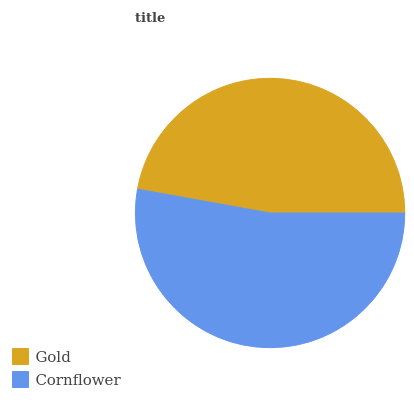Is Gold the minimum?
Answer yes or no. Yes. Is Cornflower the maximum?
Answer yes or no. Yes. Is Cornflower the minimum?
Answer yes or no. No. Is Cornflower greater than Gold?
Answer yes or no. Yes. Is Gold less than Cornflower?
Answer yes or no. Yes. Is Gold greater than Cornflower?
Answer yes or no. No. Is Cornflower less than Gold?
Answer yes or no. No. Is Cornflower the high median?
Answer yes or no. Yes. Is Gold the low median?
Answer yes or no. Yes. Is Gold the high median?
Answer yes or no. No. Is Cornflower the low median?
Answer yes or no. No. 